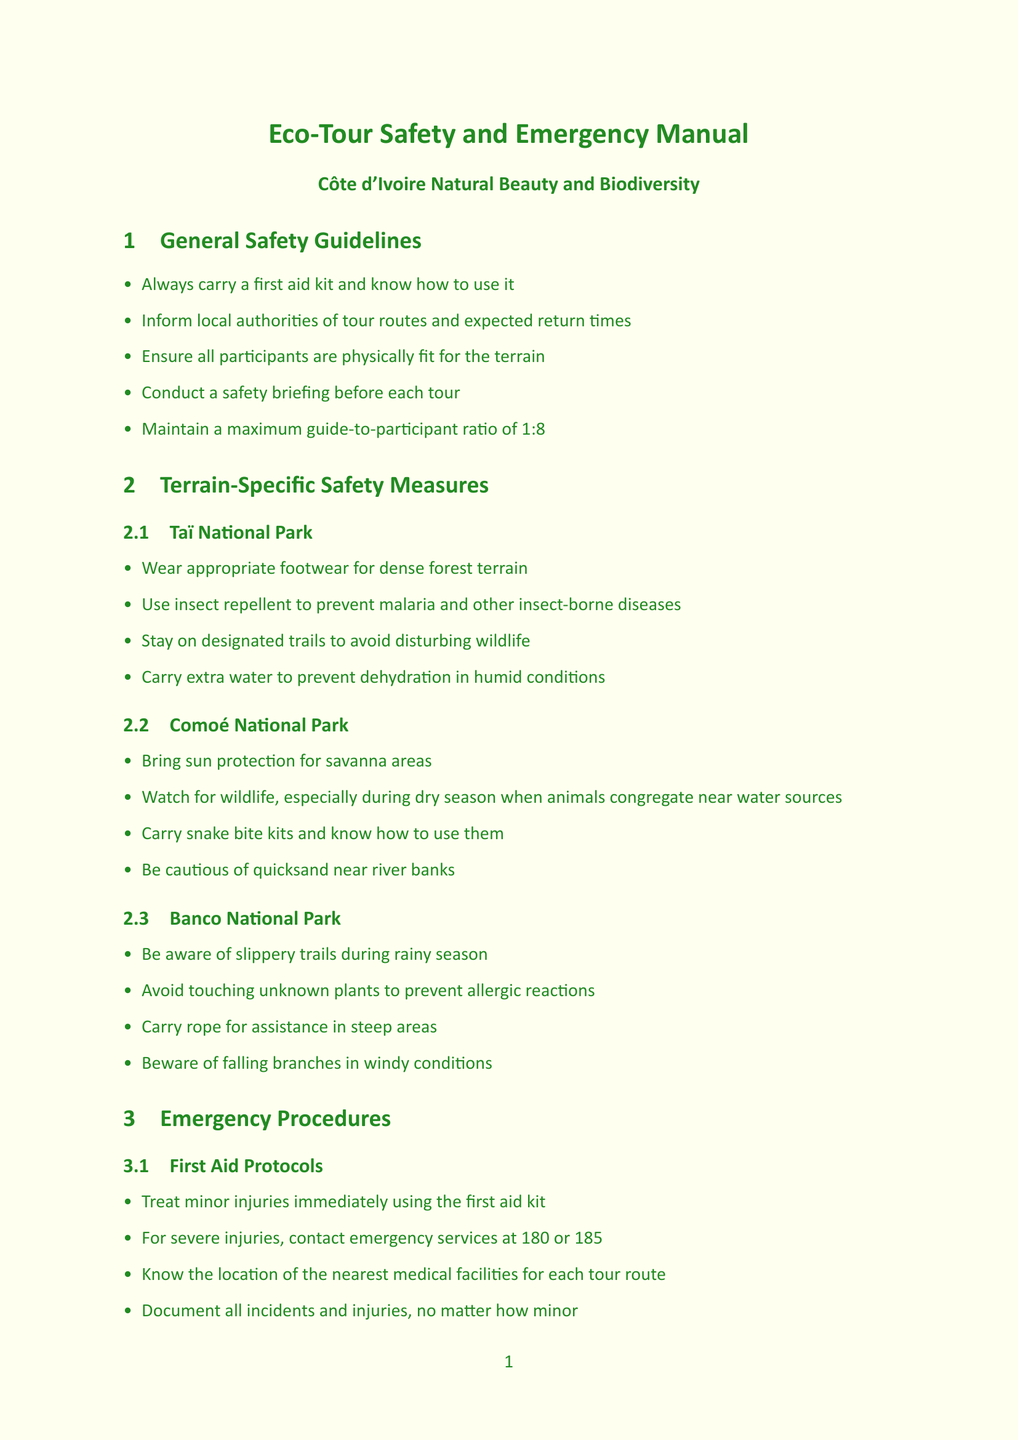What is the maximum guide-to-participant ratio for tours? The document states that the ratio should not exceed 1:8, ensuring all participants are adequately supervised.
Answer: 1:8 Which phone number is designated for emergency medical services in Côte d'Ivoire? The document lists the ambulance and SAMU (Emergency Medical Services) number as 185.
Answer: 185 What type of footwear should be worn in Taï National Park? The guidelines specifically mention wearing appropriate footwear suitable for dense forest terrain to ensure safety during the tour.
Answer: Appropriate footwear How should extreme heat risk be managed during tours? The document advises starting tours early in the morning and ensuring participants have sufficient water, as part of the mitigation strategies for extreme heat.
Answer: Start tours early and carry sufficient water What is one mandatory training requirement for eco-tour guides? The document lists several training requirements including First Aid and CPR certification from the Ivorian Red Cross.
Answer: First Aid and CPR certification What should participants avoid during the rainy season according to weather-related risks? The document advises avoiding low-lying areas during the rainy season (May to November) due to the risk of heavy rainfall and flooding.
Answer: Avoid low-lying areas Which communication system requires carrying spare batteries? The two-way radios are noted in the document as necessitating the carrying of spare batteries for effective communication during the tour.
Answer: Two-way radios Where is the CHU de Cocody located? The document lists CHU de Cocody as located in Abidjan, providing key information on medical facilities.
Answer: Abidjan 